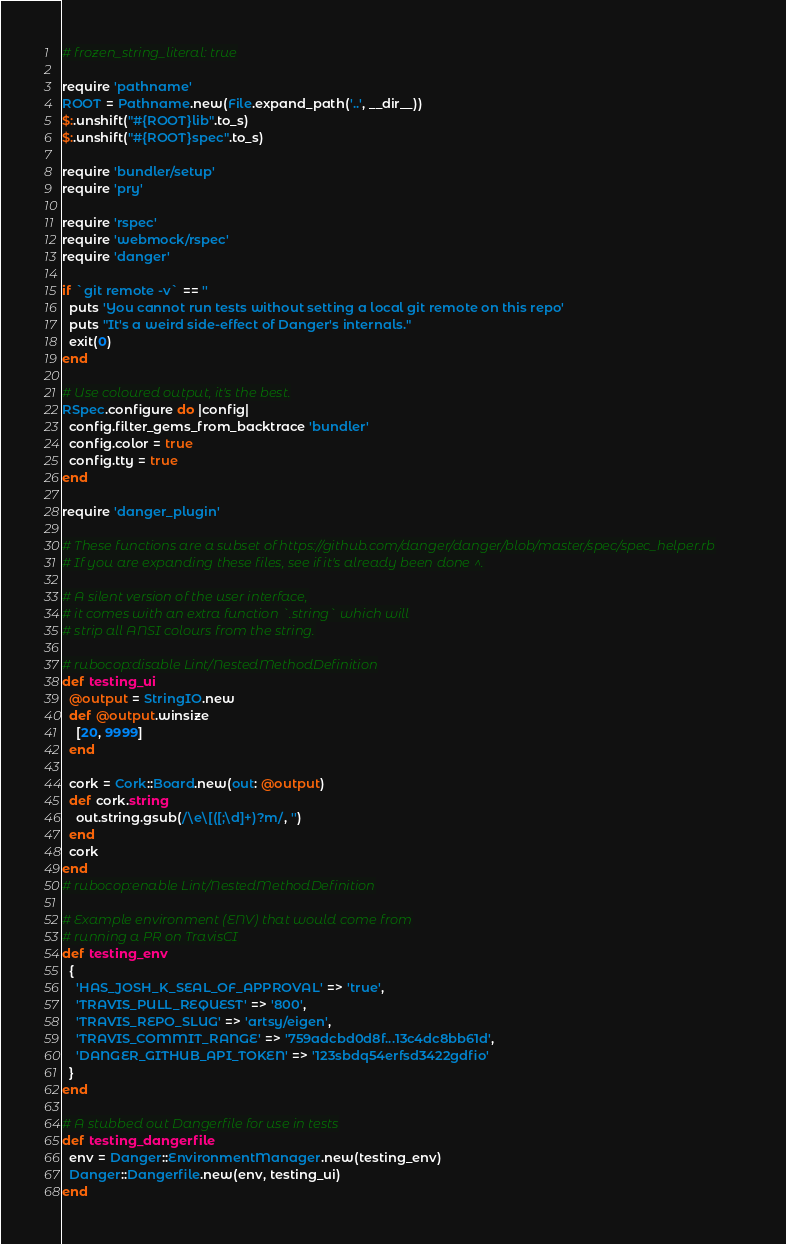Convert code to text. <code><loc_0><loc_0><loc_500><loc_500><_Ruby_># frozen_string_literal: true

require 'pathname'
ROOT = Pathname.new(File.expand_path('..', __dir__))
$:.unshift("#{ROOT}lib".to_s)
$:.unshift("#{ROOT}spec".to_s)

require 'bundler/setup'
require 'pry'

require 'rspec'
require 'webmock/rspec'
require 'danger'

if `git remote -v` == ''
  puts 'You cannot run tests without setting a local git remote on this repo'
  puts "It's a weird side-effect of Danger's internals."
  exit(0)
end

# Use coloured output, it's the best.
RSpec.configure do |config|
  config.filter_gems_from_backtrace 'bundler'
  config.color = true
  config.tty = true
end

require 'danger_plugin'

# These functions are a subset of https://github.com/danger/danger/blob/master/spec/spec_helper.rb
# If you are expanding these files, see if it's already been done ^.

# A silent version of the user interface,
# it comes with an extra function `.string` which will
# strip all ANSI colours from the string.

# rubocop:disable Lint/NestedMethodDefinition
def testing_ui
  @output = StringIO.new
  def @output.winsize
    [20, 9999]
  end

  cork = Cork::Board.new(out: @output)
  def cork.string
    out.string.gsub(/\e\[([;\d]+)?m/, '')
  end
  cork
end
# rubocop:enable Lint/NestedMethodDefinition

# Example environment (ENV) that would come from
# running a PR on TravisCI
def testing_env
  {
    'HAS_JOSH_K_SEAL_OF_APPROVAL' => 'true',
    'TRAVIS_PULL_REQUEST' => '800',
    'TRAVIS_REPO_SLUG' => 'artsy/eigen',
    'TRAVIS_COMMIT_RANGE' => '759adcbd0d8f...13c4dc8bb61d',
    'DANGER_GITHUB_API_TOKEN' => '123sbdq54erfsd3422gdfio'
  }
end

# A stubbed out Dangerfile for use in tests
def testing_dangerfile
  env = Danger::EnvironmentManager.new(testing_env)
  Danger::Dangerfile.new(env, testing_ui)
end
</code> 